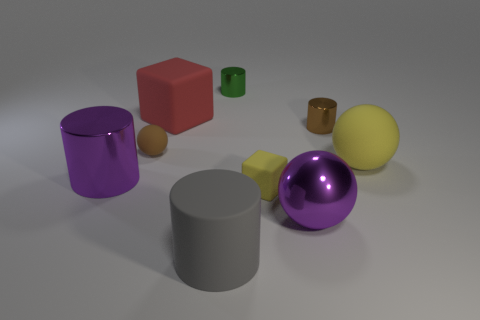Add 1 purple metal cylinders. How many objects exist? 10 Subtract all red cylinders. Subtract all brown spheres. How many cylinders are left? 4 Subtract all spheres. How many objects are left? 6 Add 5 large metal things. How many large metal things are left? 7 Add 8 large metal cylinders. How many large metal cylinders exist? 9 Subtract 1 red cubes. How many objects are left? 8 Subtract all big matte cylinders. Subtract all matte cylinders. How many objects are left? 7 